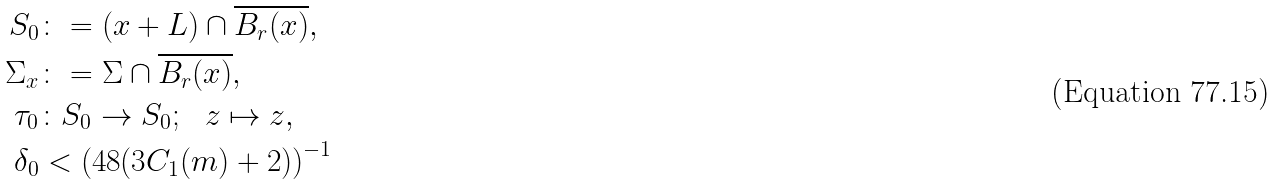Convert formula to latex. <formula><loc_0><loc_0><loc_500><loc_500>S _ { 0 } & \colon = ( x + L ) \cap \overline { B _ { r } ( x ) } , \\ \Sigma _ { x } & \colon = \Sigma \cap \overline { B _ { r } ( x ) } , \\ \tau _ { 0 } & \colon S _ { 0 } \to S _ { 0 } ; \ \ z \mapsto z , \\ \delta _ { 0 } & < \left ( 4 8 ( 3 C _ { 1 } ( m ) + 2 ) \right ) ^ { - 1 }</formula> 